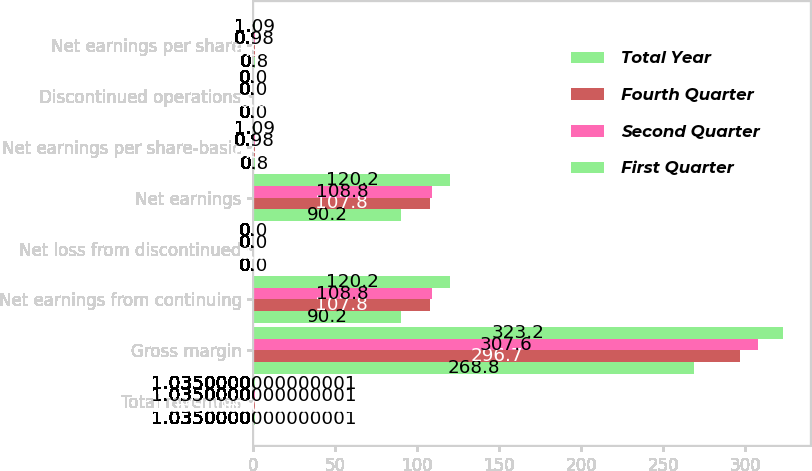<chart> <loc_0><loc_0><loc_500><loc_500><stacked_bar_chart><ecel><fcel>Total revenues<fcel>Gross margin<fcel>Net earnings from continuing<fcel>Net loss from discontinued<fcel>Net earnings<fcel>Net earnings per share-basic<fcel>Discontinued operations<fcel>Net earnings per share<nl><fcel>Total Year<fcel>1.035<fcel>268.8<fcel>90.2<fcel>0<fcel>90.2<fcel>0.8<fcel>0<fcel>0.8<nl><fcel>Fourth Quarter<fcel>1.035<fcel>296.7<fcel>107.8<fcel>0<fcel>107.8<fcel>0.96<fcel>0<fcel>0.96<nl><fcel>Second Quarter<fcel>1.035<fcel>307.6<fcel>108.8<fcel>0<fcel>108.8<fcel>0.98<fcel>0<fcel>0.98<nl><fcel>First Quarter<fcel>1.035<fcel>323.2<fcel>120.2<fcel>0<fcel>120.2<fcel>1.09<fcel>0<fcel>1.09<nl></chart> 